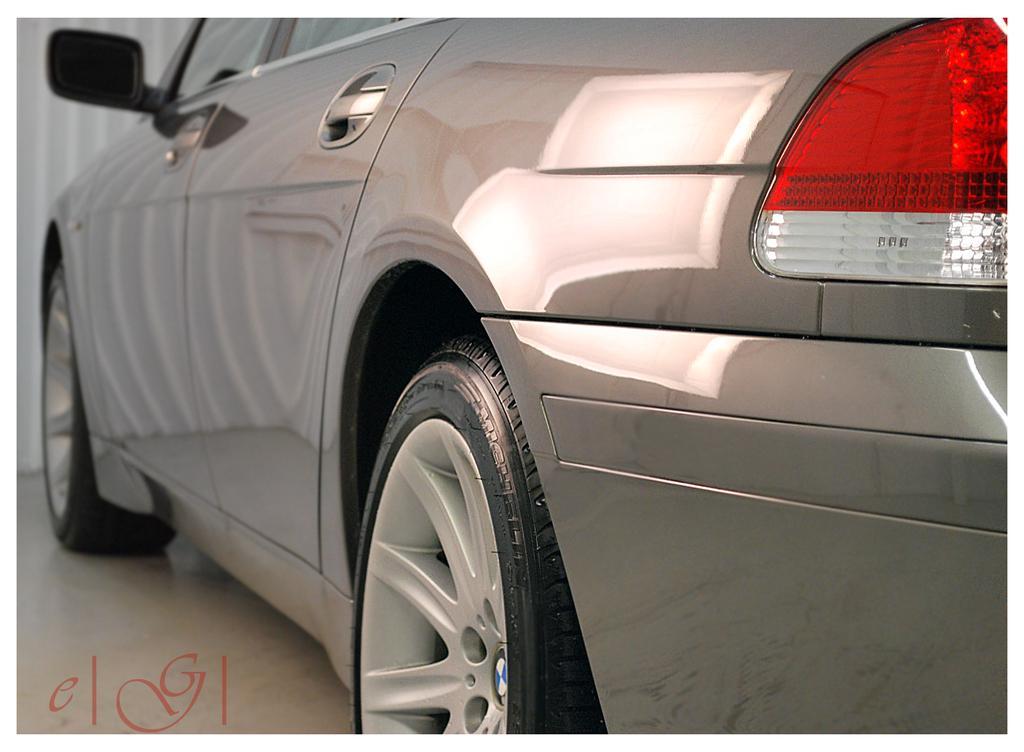In one or two sentences, can you explain what this image depicts? On the right side, there is a gray color vehicle parked on the floor. And the background is white in color. 